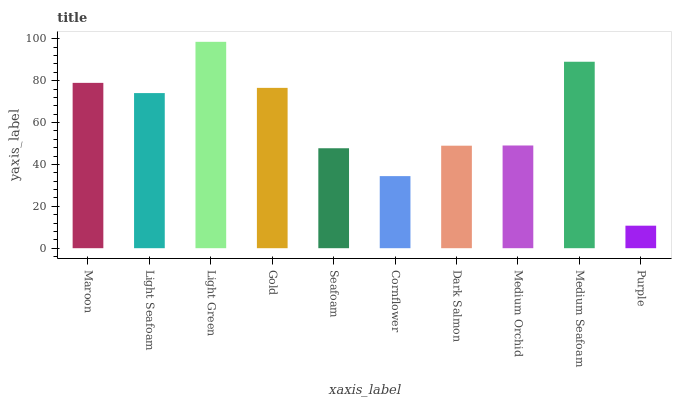Is Purple the minimum?
Answer yes or no. Yes. Is Light Green the maximum?
Answer yes or no. Yes. Is Light Seafoam the minimum?
Answer yes or no. No. Is Light Seafoam the maximum?
Answer yes or no. No. Is Maroon greater than Light Seafoam?
Answer yes or no. Yes. Is Light Seafoam less than Maroon?
Answer yes or no. Yes. Is Light Seafoam greater than Maroon?
Answer yes or no. No. Is Maroon less than Light Seafoam?
Answer yes or no. No. Is Light Seafoam the high median?
Answer yes or no. Yes. Is Medium Orchid the low median?
Answer yes or no. Yes. Is Cornflower the high median?
Answer yes or no. No. Is Light Seafoam the low median?
Answer yes or no. No. 